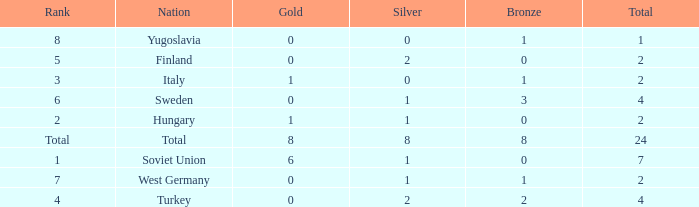What is the average Bronze, when Total is 7, and when Silver is greater than 1? None. 